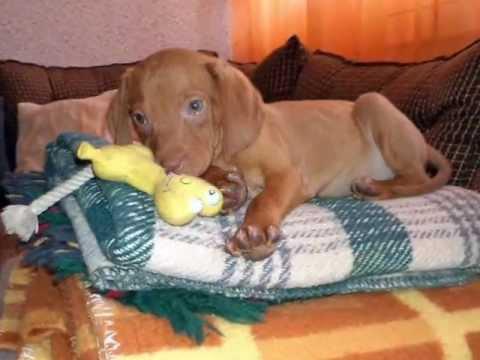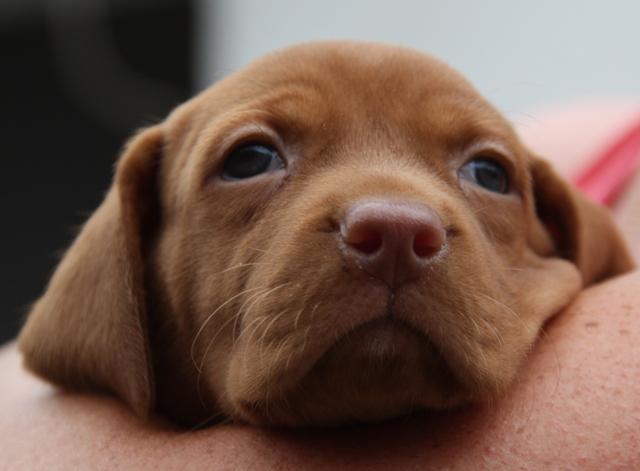The first image is the image on the left, the second image is the image on the right. Given the left and right images, does the statement "An image shows exactly one dog reclining on a soft piece of furniture, with its rear to the right and its head to the left." hold true? Answer yes or no. Yes. The first image is the image on the left, the second image is the image on the right. Given the left and right images, does the statement "There are no more than two dogs." hold true? Answer yes or no. Yes. 